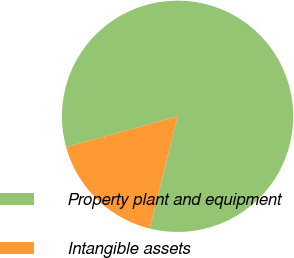<chart> <loc_0><loc_0><loc_500><loc_500><pie_chart><fcel>Property plant and equipment<fcel>Intangible assets<nl><fcel>83.18%<fcel>16.82%<nl></chart> 